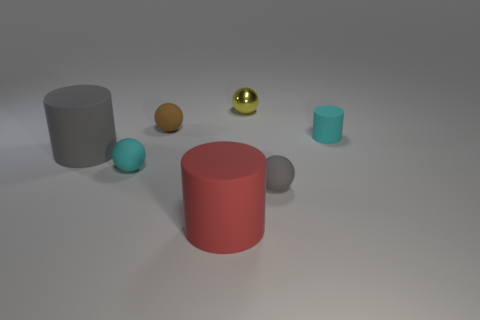How do the objects in this image vary in texture and reflectivity? The objects in this image display a range of textures and reflectivity. The gray cylinder has a matte texture, causing it to absorb light, giving it a flat appearance. In contrast, the golden sphere has a highly reflective surface that mirrors its surroundings, which makes it appear shiny. The red cylinder seems to have a slightly velvety surface, which mildly reflects light, while the brown sphere has a less reflective surface compared to the gold sphere but is more reflective than the cyan objects. 